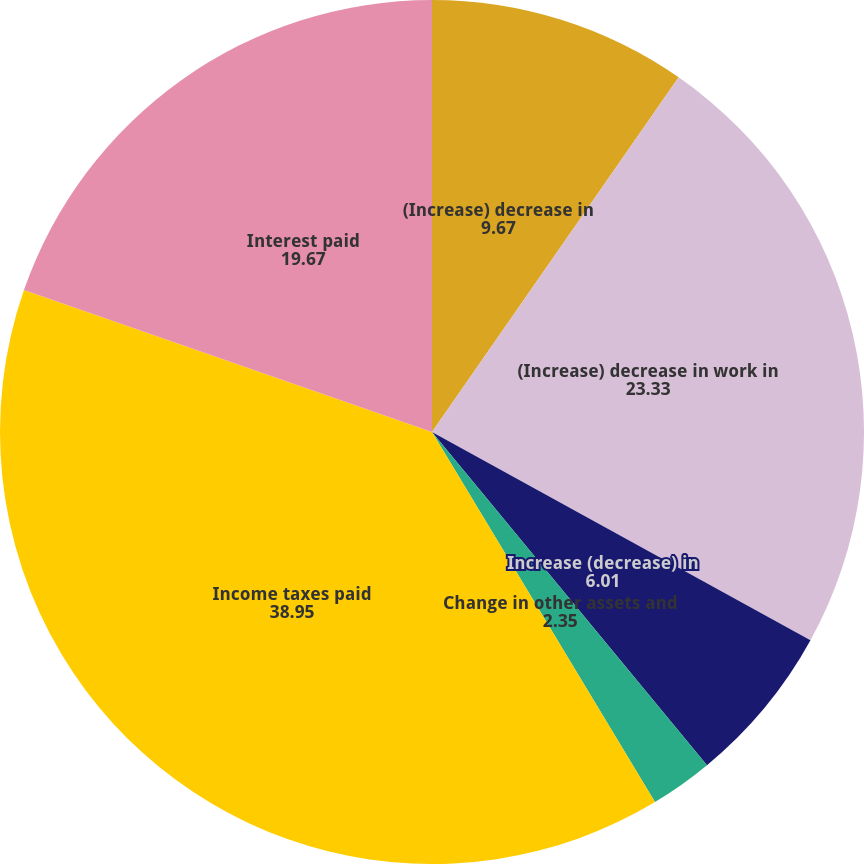Convert chart. <chart><loc_0><loc_0><loc_500><loc_500><pie_chart><fcel>(Increase) decrease in<fcel>(Increase) decrease in work in<fcel>Increase (decrease) in<fcel>Change in other assets and<fcel>Income taxes paid<fcel>Interest paid<nl><fcel>9.67%<fcel>23.33%<fcel>6.01%<fcel>2.35%<fcel>38.95%<fcel>19.67%<nl></chart> 